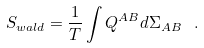<formula> <loc_0><loc_0><loc_500><loc_500>S _ { w a l d } = \frac { 1 } { T } \int Q ^ { A B } d \Sigma _ { A B } \ .</formula> 